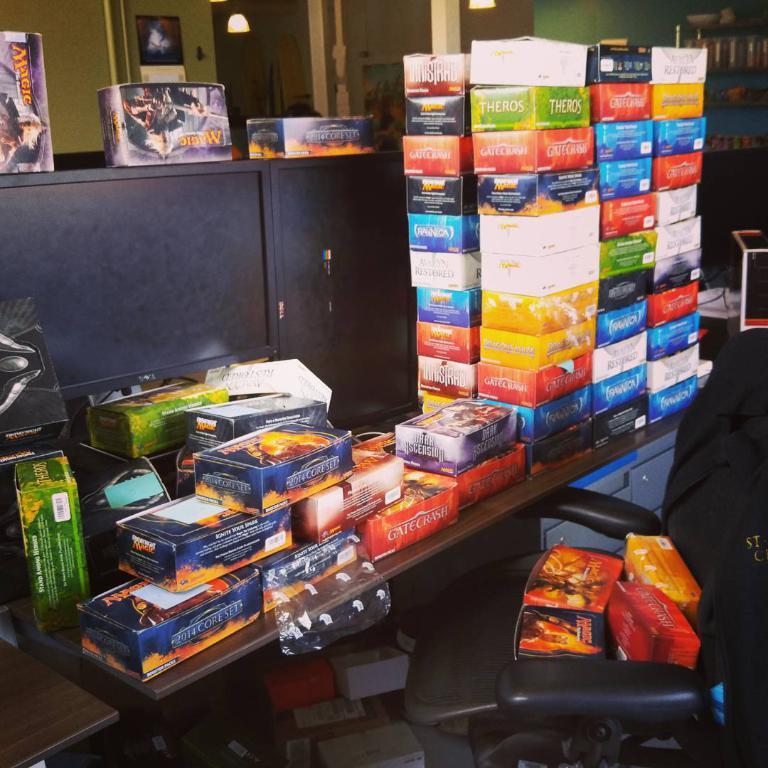What type of furniture is present in the image? There is a chair in the image. What can be seen illuminating the scene in the image? There are lights in the image. What type of storage unit is visible in the image? There is a wooden drawer in the image. What is on the wooden table in the image? There are objects on a wooden table in the image. What type of apparel is being worn by the chicken in the image? There is no chicken present in the image, so it is not possible to determine what type of apparel it might be wearing. 